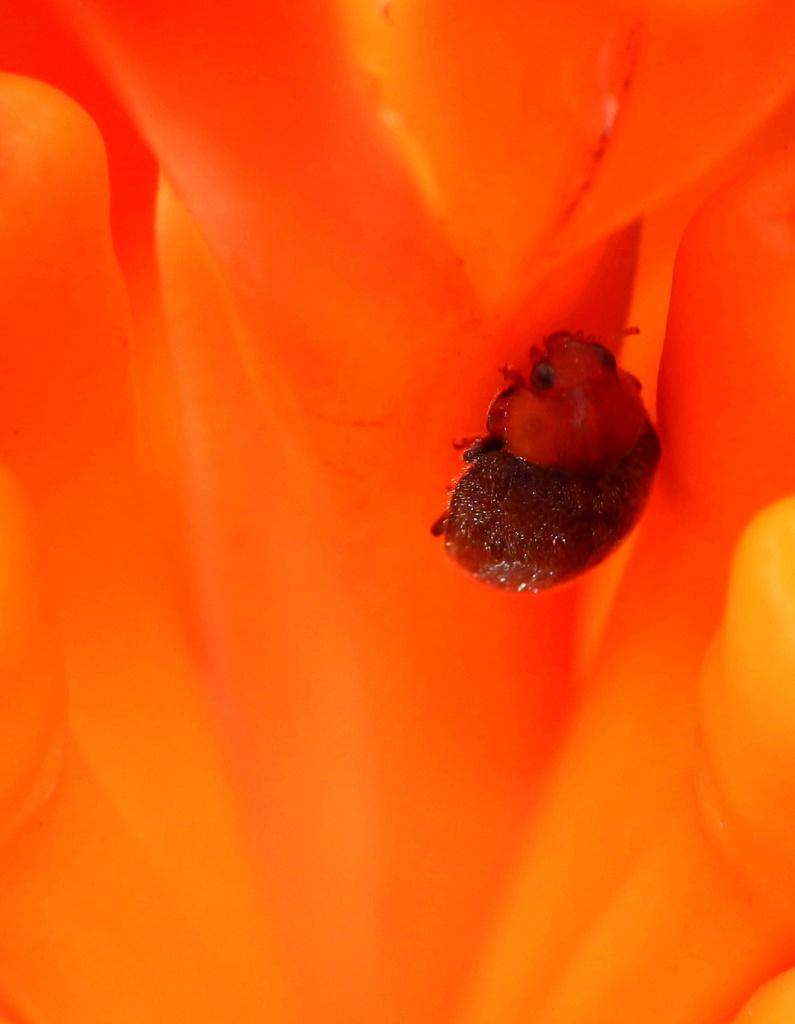What type of creature can be seen in the image? There is an insect in the image. Where is the insect located in the image? The insect is on the right side of the image. What color is the background of the image? The background of the image appears to be orange in color. How many tickets can be seen in the image? There are no tickets present in the image. What type of bird is sitting on the insect in the image? There is no bird, such as an owl, present in the image. 